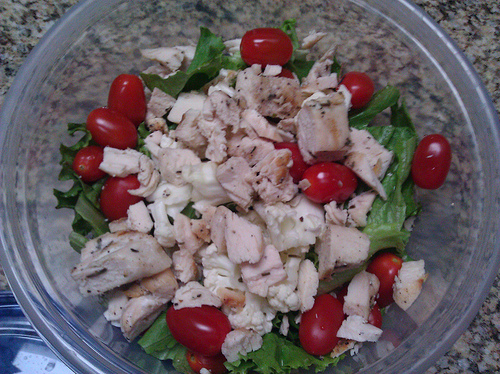<image>
Is the cherry in front of the bread? No. The cherry is not in front of the bread. The spatial positioning shows a different relationship between these objects. 